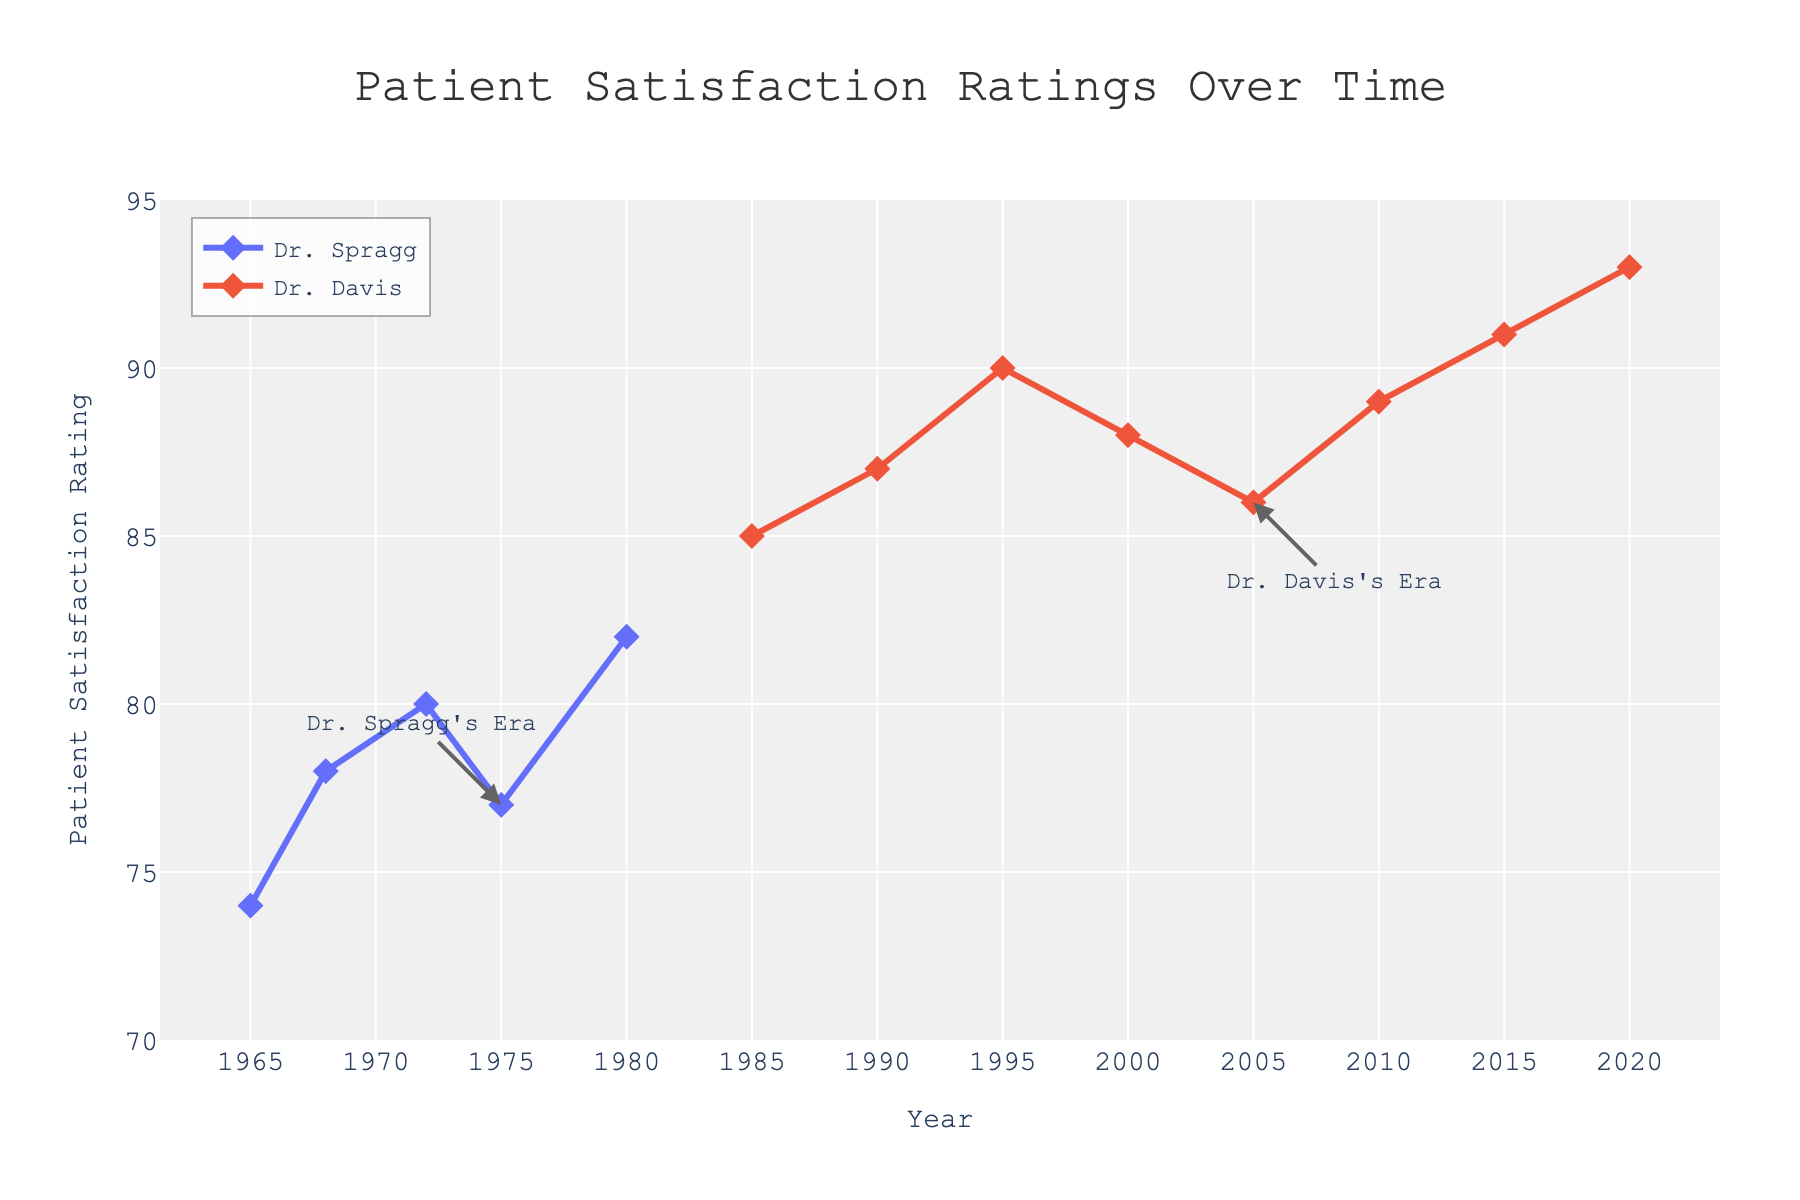What is the title of the figure? The title is located at the top of the figure, typically in larger font size than other text elements. The title helps to understand the main topic of the plot.
Answer: Patient Satisfaction Ratings Over Time What are the highest and lowest patient satisfaction ratings recorded in the figure? The highest and lowest values are noted by looking at the maximum and minimum points on the y-axis, which represents the patient satisfaction ratings.
Answer: Highest: 93, Lowest: 74 Which years are annotated as the era transitions for Dr. Spragg and Dr. Davis? The annotations on the figure provide information about specific years marking transitions. These can be found by locating text with arrows pointing to the respective years.
Answer: Dr. Spragg's Era: 1975, Dr. Davis's Era: 2005 What is the average patient satisfaction rating during Dr. Spragg's era? To find the average, sum all patient satisfaction ratings from Dr. Spragg’s years and divide by the number of those years. Years: 1965, 1968, 1972, 1975, 1980. Ratings: 74, 78, 80, 77, 82. Sum: 74 + 78 + 80 + 77 + 82 = 391. Average = 391 / 5 = 78.2.
Answer: 78.2 What is the overall trend of patient satisfaction ratings over the years from 1965 to 2020? The overall trend can be identified by examining the general direction of the data points in the scatter plot. If the points show an upward movement from left to right, the trend is increasing. Conversely, if the points show a downward movement, the trend is decreasing.
Answer: Increasing Between which two consecutive years did Dr. Davis achieve the highest increase in patient satisfaction ratings? Calculate the difference in patient satisfaction ratings for each pair of consecutive years for Dr. Davis. Identify the pair with the largest positive difference: (1990-1985: 87-85 = 2), (1995-1990: 90-87 = 3), (2000-1995: 88-90 = -2), (2005-2000: 86-88 = -2), (2010-2005: 89-86 = 3), (2015-2010: 91-89 = 2), (2020-2015: 93-91 = 2). The largest increase is between 1995 and 1990, and 2010 and 2005 being equal highest.
Answer: 1995-1990 and 2010-2005 Which doctor had a higher average patient satisfaction rating within their respective eras? Calculate the averages for both doctors and compare them. 
Dr. Spragg's era: (74+78+80+77+82) / 5 = 78.2. 
Dr. Davis's era: (85+87+90+88+86+89+91+93) / 8 = 88.625. Compare the two averages: Dr. Davis's average (88.625) is higher than Dr. Spragg's average (78.2).
Answer: Dr. Davis How many total years of data are represented in the figure? Count the number of unique years listed across the x-axis.
Answer: 13 What is the range of patient satisfaction ratings during Dr. Davis's era? Identify the highest and lowest patient satisfaction ratings during Dr. Davis's era and subtract the lowest from the highest. Ratings: 85, 87, 90, 88, 86, 89, 91, 93. Highest: 93, Lowest: 85. Range: 93 - 85.
Answer: 8 Between which two consecutive years did Dr. Spragg experience a decrease in patient satisfaction ratings? Calculate the difference in patient satisfaction ratings for each pair of consecutive years for Dr. Spragg. Look for a negative difference: (1968-1965: 78-74 = 4), (1972-1968: 80-78 = 2), (1975-1972: 77-80 = -3), (1980-1975: 82-77 = 5). The decrease occurred between 1975 and 1972.
Answer: 1975-1972 